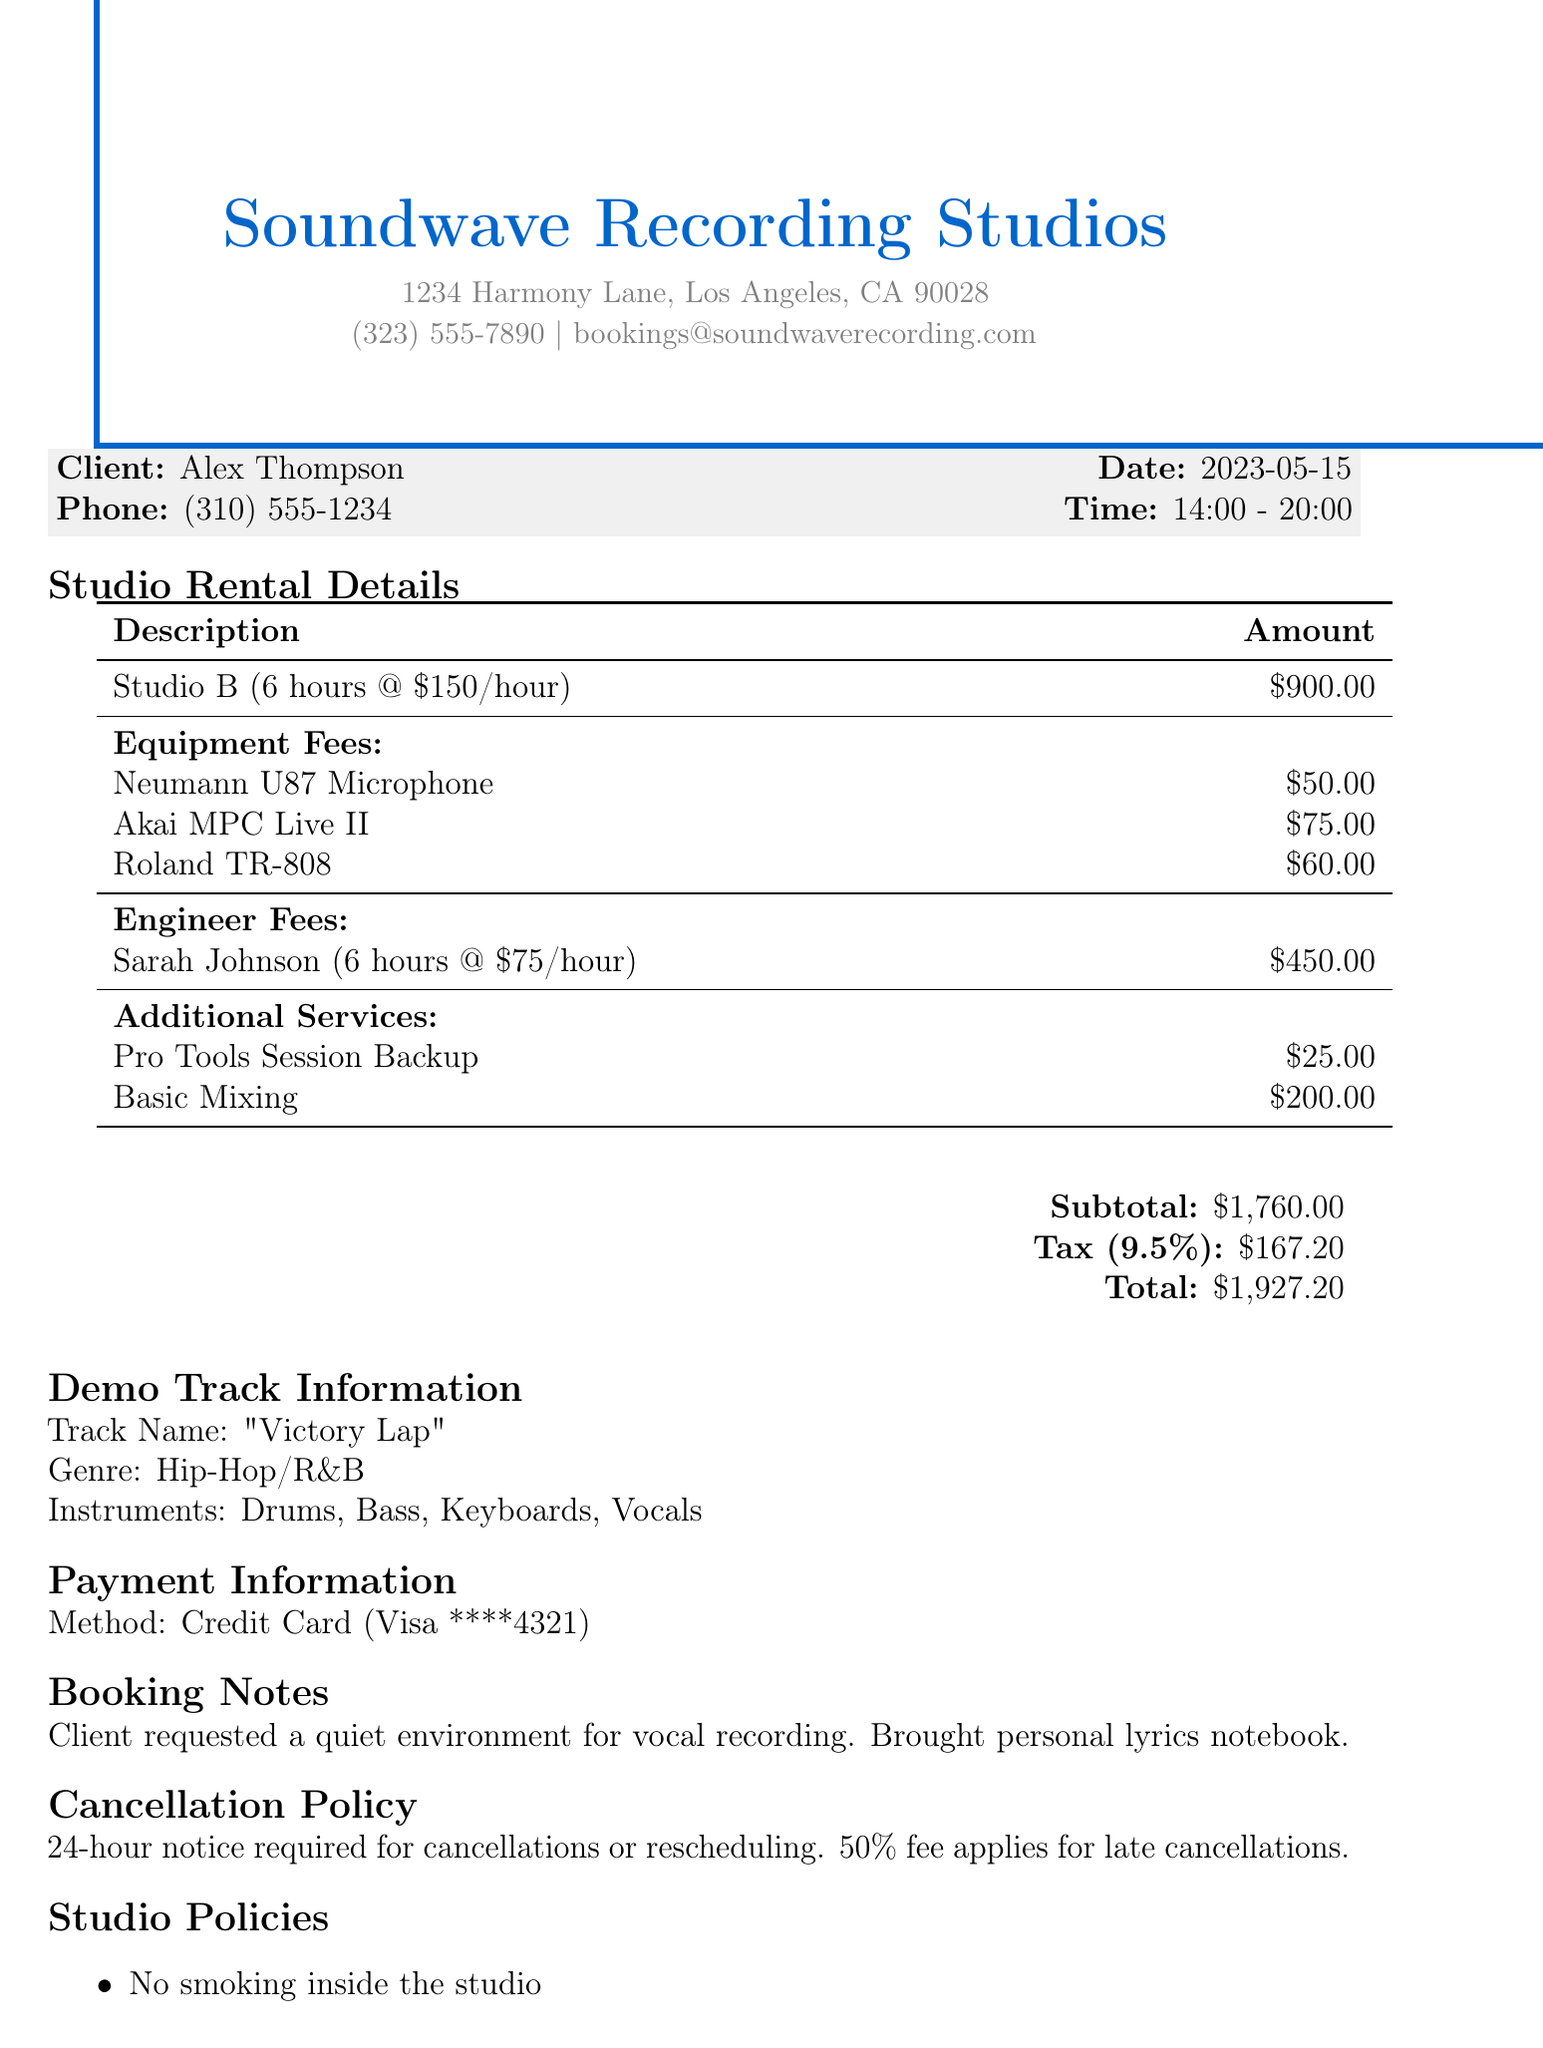What is the studio name? The studio name is mentioned at the top of the document as "Soundwave Recording Studios."
Answer: Soundwave Recording Studios What is the total amount charged? The total amount is found in the summary section of the document where the final amount is specified.
Answer: $1,927.20 Who is the engineer assigned? The engineer's name is provided in the details about the engineer fees in the document.
Answer: Sarah Johnson What was the duration of studio rental? The hours of studio rental can be found in the rental details section; it specifies the rental period in hours.
Answer: 6 hours What genre is the demo track? The genre information is included in the demo track information section of the document.
Answer: Hip-Hop/R&B How much were the equipment fees? The equipment fees total is clearly stated under the equipment fees section of the document.
Answer: $185 What is the cancellation policy? The cancellation policy is summarized at the end of the document regarding notice requirements and fees.
Answer: 24-hour notice required for cancellations or rescheduling Which payment method was used? The payment method is listed in the payment information section of the document.
Answer: Credit Card What instruments were used in the track? The instruments used are listed in the demo track information section of the document.
Answer: Drums, Bass, Keyboards, Vocals 